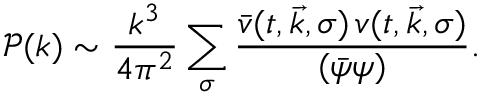Convert formula to latex. <formula><loc_0><loc_0><loc_500><loc_500>\mathcal { P } ( k ) \sim \frac { k ^ { 3 } } { 4 \pi ^ { 2 } } \sum _ { \sigma } \frac { \bar { v } ( t , \vec { k } , \sigma ) \, v ( t , \vec { k } , \sigma ) } { ( \bar { \psi } \psi ) } .</formula> 